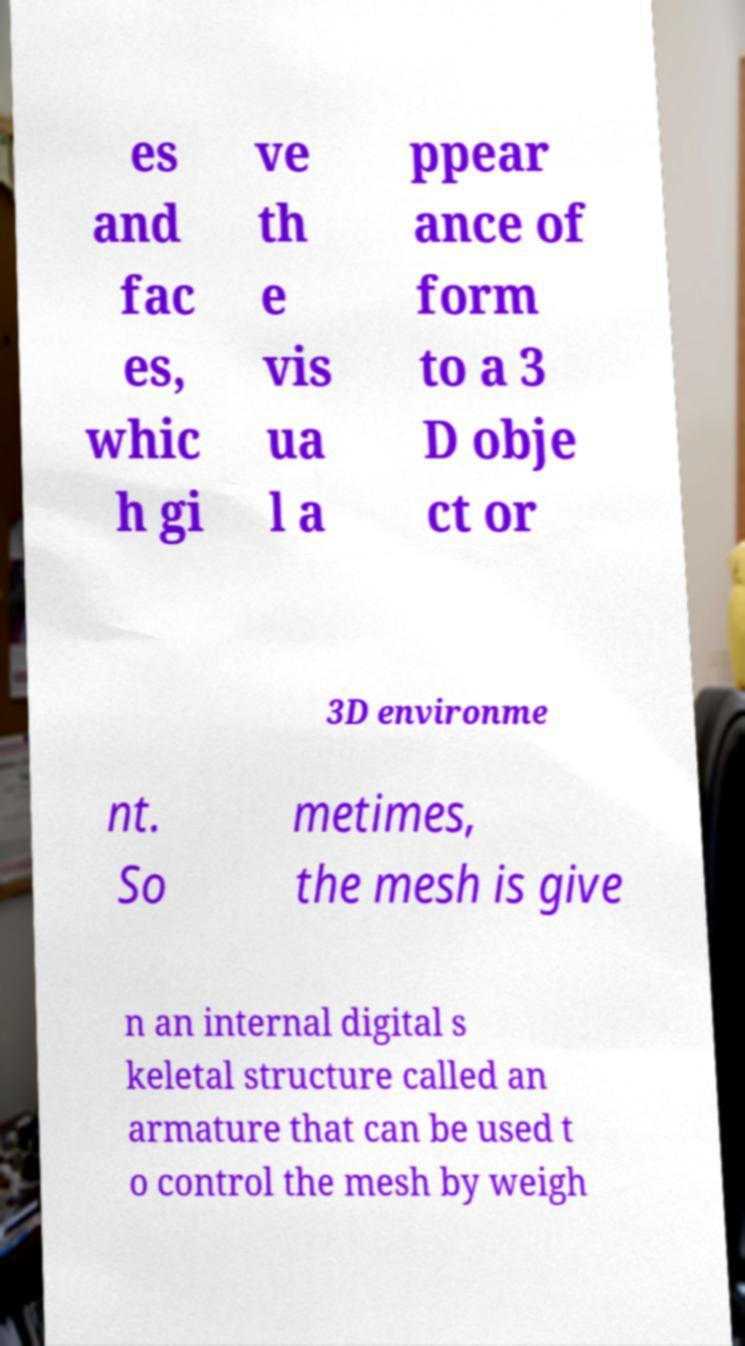I need the written content from this picture converted into text. Can you do that? es and fac es, whic h gi ve th e vis ua l a ppear ance of form to a 3 D obje ct or 3D environme nt. So metimes, the mesh is give n an internal digital s keletal structure called an armature that can be used t o control the mesh by weigh 